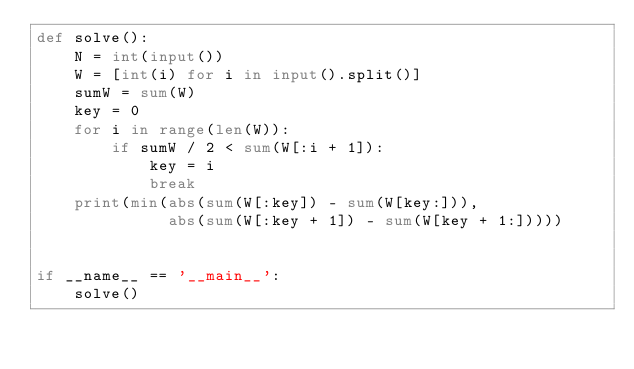Convert code to text. <code><loc_0><loc_0><loc_500><loc_500><_Python_>def solve():
    N = int(input())
    W = [int(i) for i in input().split()]
    sumW = sum(W)
    key = 0
    for i in range(len(W)):
        if sumW / 2 < sum(W[:i + 1]):
            key = i
            break
    print(min(abs(sum(W[:key]) - sum(W[key:])),
              abs(sum(W[:key + 1]) - sum(W[key + 1:]))))


if __name__ == '__main__':
    solve()
</code> 